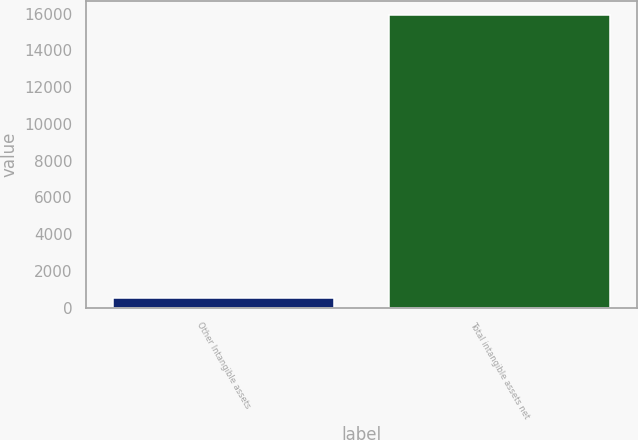Convert chart. <chart><loc_0><loc_0><loc_500><loc_500><bar_chart><fcel>Other Intangible assets<fcel>Total intangible assets net<nl><fcel>500<fcel>15910<nl></chart> 